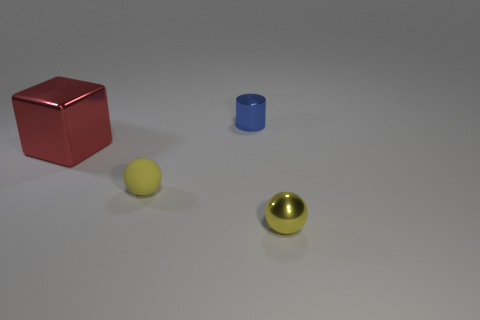How many small metallic spheres are the same color as the matte thing?
Provide a short and direct response. 1. Is the color of the matte sphere the same as the small metallic thing in front of the metal cube?
Offer a terse response. Yes. There is a small thing behind the big metal block; are there any small shiny objects that are in front of it?
Keep it short and to the point. Yes. How many blocks are tiny rubber objects or large yellow shiny things?
Ensure brevity in your answer.  0. There is a ball that is left of the sphere to the right of the metallic thing that is behind the large red object; what size is it?
Offer a very short reply. Small. Are there any small objects on the left side of the tiny blue metallic thing?
Give a very brief answer. Yes. There is a tiny matte thing that is the same color as the tiny metallic ball; what shape is it?
Ensure brevity in your answer.  Sphere. What number of objects are yellow objects left of the tiny yellow metallic sphere or large cubes?
Your response must be concise. 2. What is the size of the yellow object that is the same material as the cylinder?
Offer a very short reply. Small. Do the yellow metallic object and the yellow sphere that is on the left side of the tiny cylinder have the same size?
Make the answer very short. Yes. 